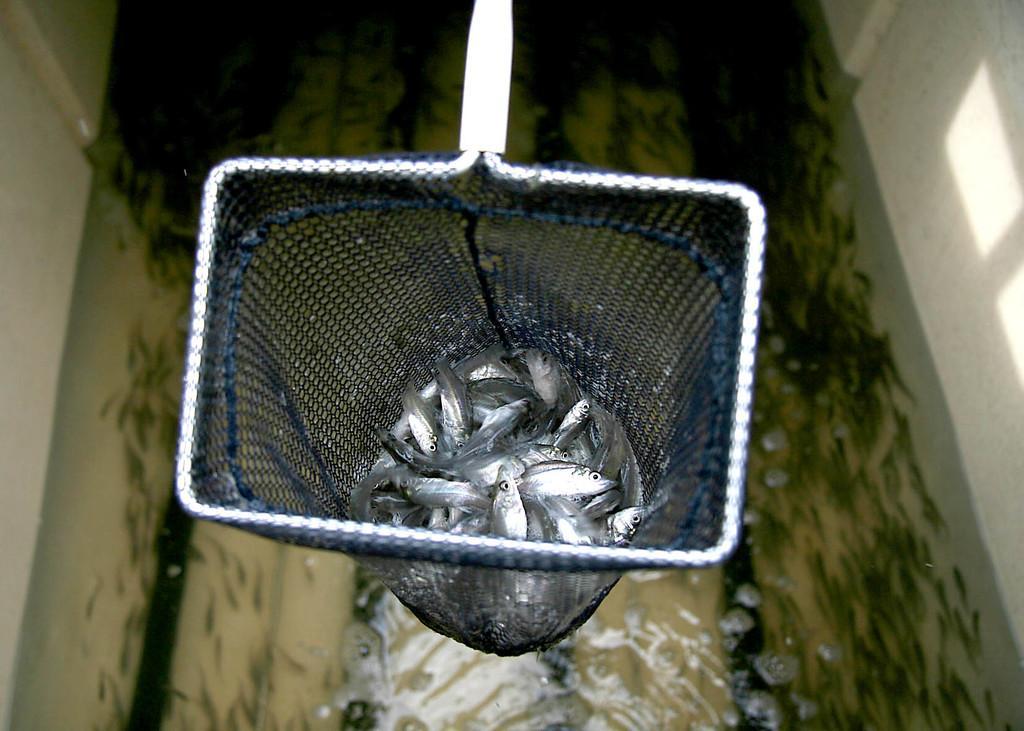How would you summarize this image in a sentence or two? In this picture we can see fishes in the scoop net. Under the scoop net, there are some fishes in the water. On the left and right side of the image, there are walls. 